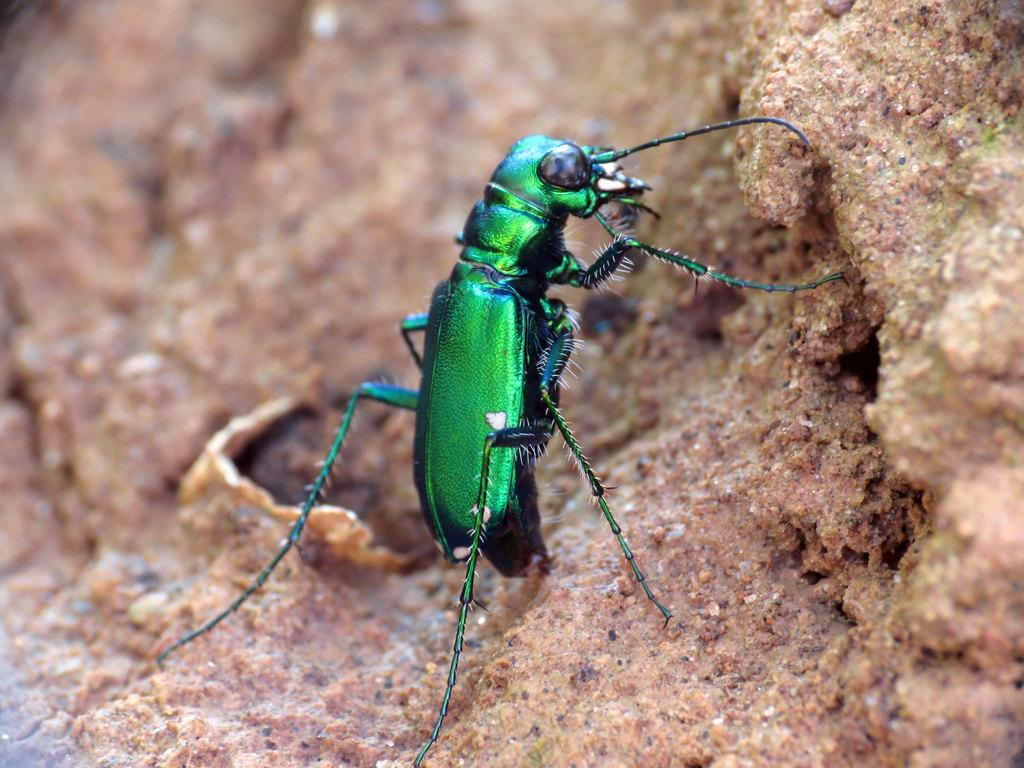What is present in the picture? There is an insect in the picture. Where is the insect located? The insect is on the ground. What color is the insect? The insect is green in color. How many kittens are playing with the donkey in the cloudy sky? There are no kittens, donkeys, or clouds present in the image; it features an insect on the ground. 